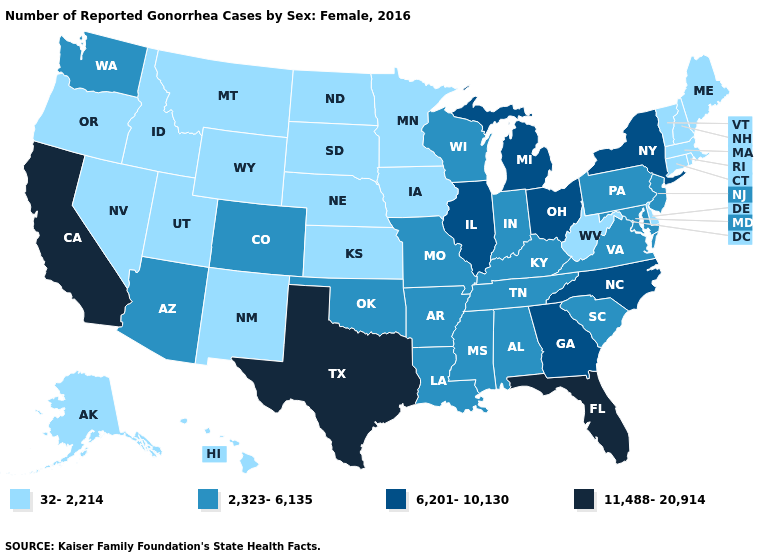Which states have the highest value in the USA?
Concise answer only. California, Florida, Texas. What is the value of Illinois?
Answer briefly. 6,201-10,130. Which states have the lowest value in the MidWest?
Answer briefly. Iowa, Kansas, Minnesota, Nebraska, North Dakota, South Dakota. What is the value of Washington?
Short answer required. 2,323-6,135. What is the value of Louisiana?
Write a very short answer. 2,323-6,135. What is the value of Missouri?
Be succinct. 2,323-6,135. Name the states that have a value in the range 6,201-10,130?
Be succinct. Georgia, Illinois, Michigan, New York, North Carolina, Ohio. Does California have the highest value in the USA?
Answer briefly. Yes. Name the states that have a value in the range 11,488-20,914?
Be succinct. California, Florida, Texas. Name the states that have a value in the range 2,323-6,135?
Be succinct. Alabama, Arizona, Arkansas, Colorado, Indiana, Kentucky, Louisiana, Maryland, Mississippi, Missouri, New Jersey, Oklahoma, Pennsylvania, South Carolina, Tennessee, Virginia, Washington, Wisconsin. How many symbols are there in the legend?
Keep it brief. 4. What is the highest value in states that border Alabama?
Concise answer only. 11,488-20,914. Which states have the highest value in the USA?
Answer briefly. California, Florida, Texas. Among the states that border Nebraska , which have the lowest value?
Give a very brief answer. Iowa, Kansas, South Dakota, Wyoming. Does the first symbol in the legend represent the smallest category?
Concise answer only. Yes. 